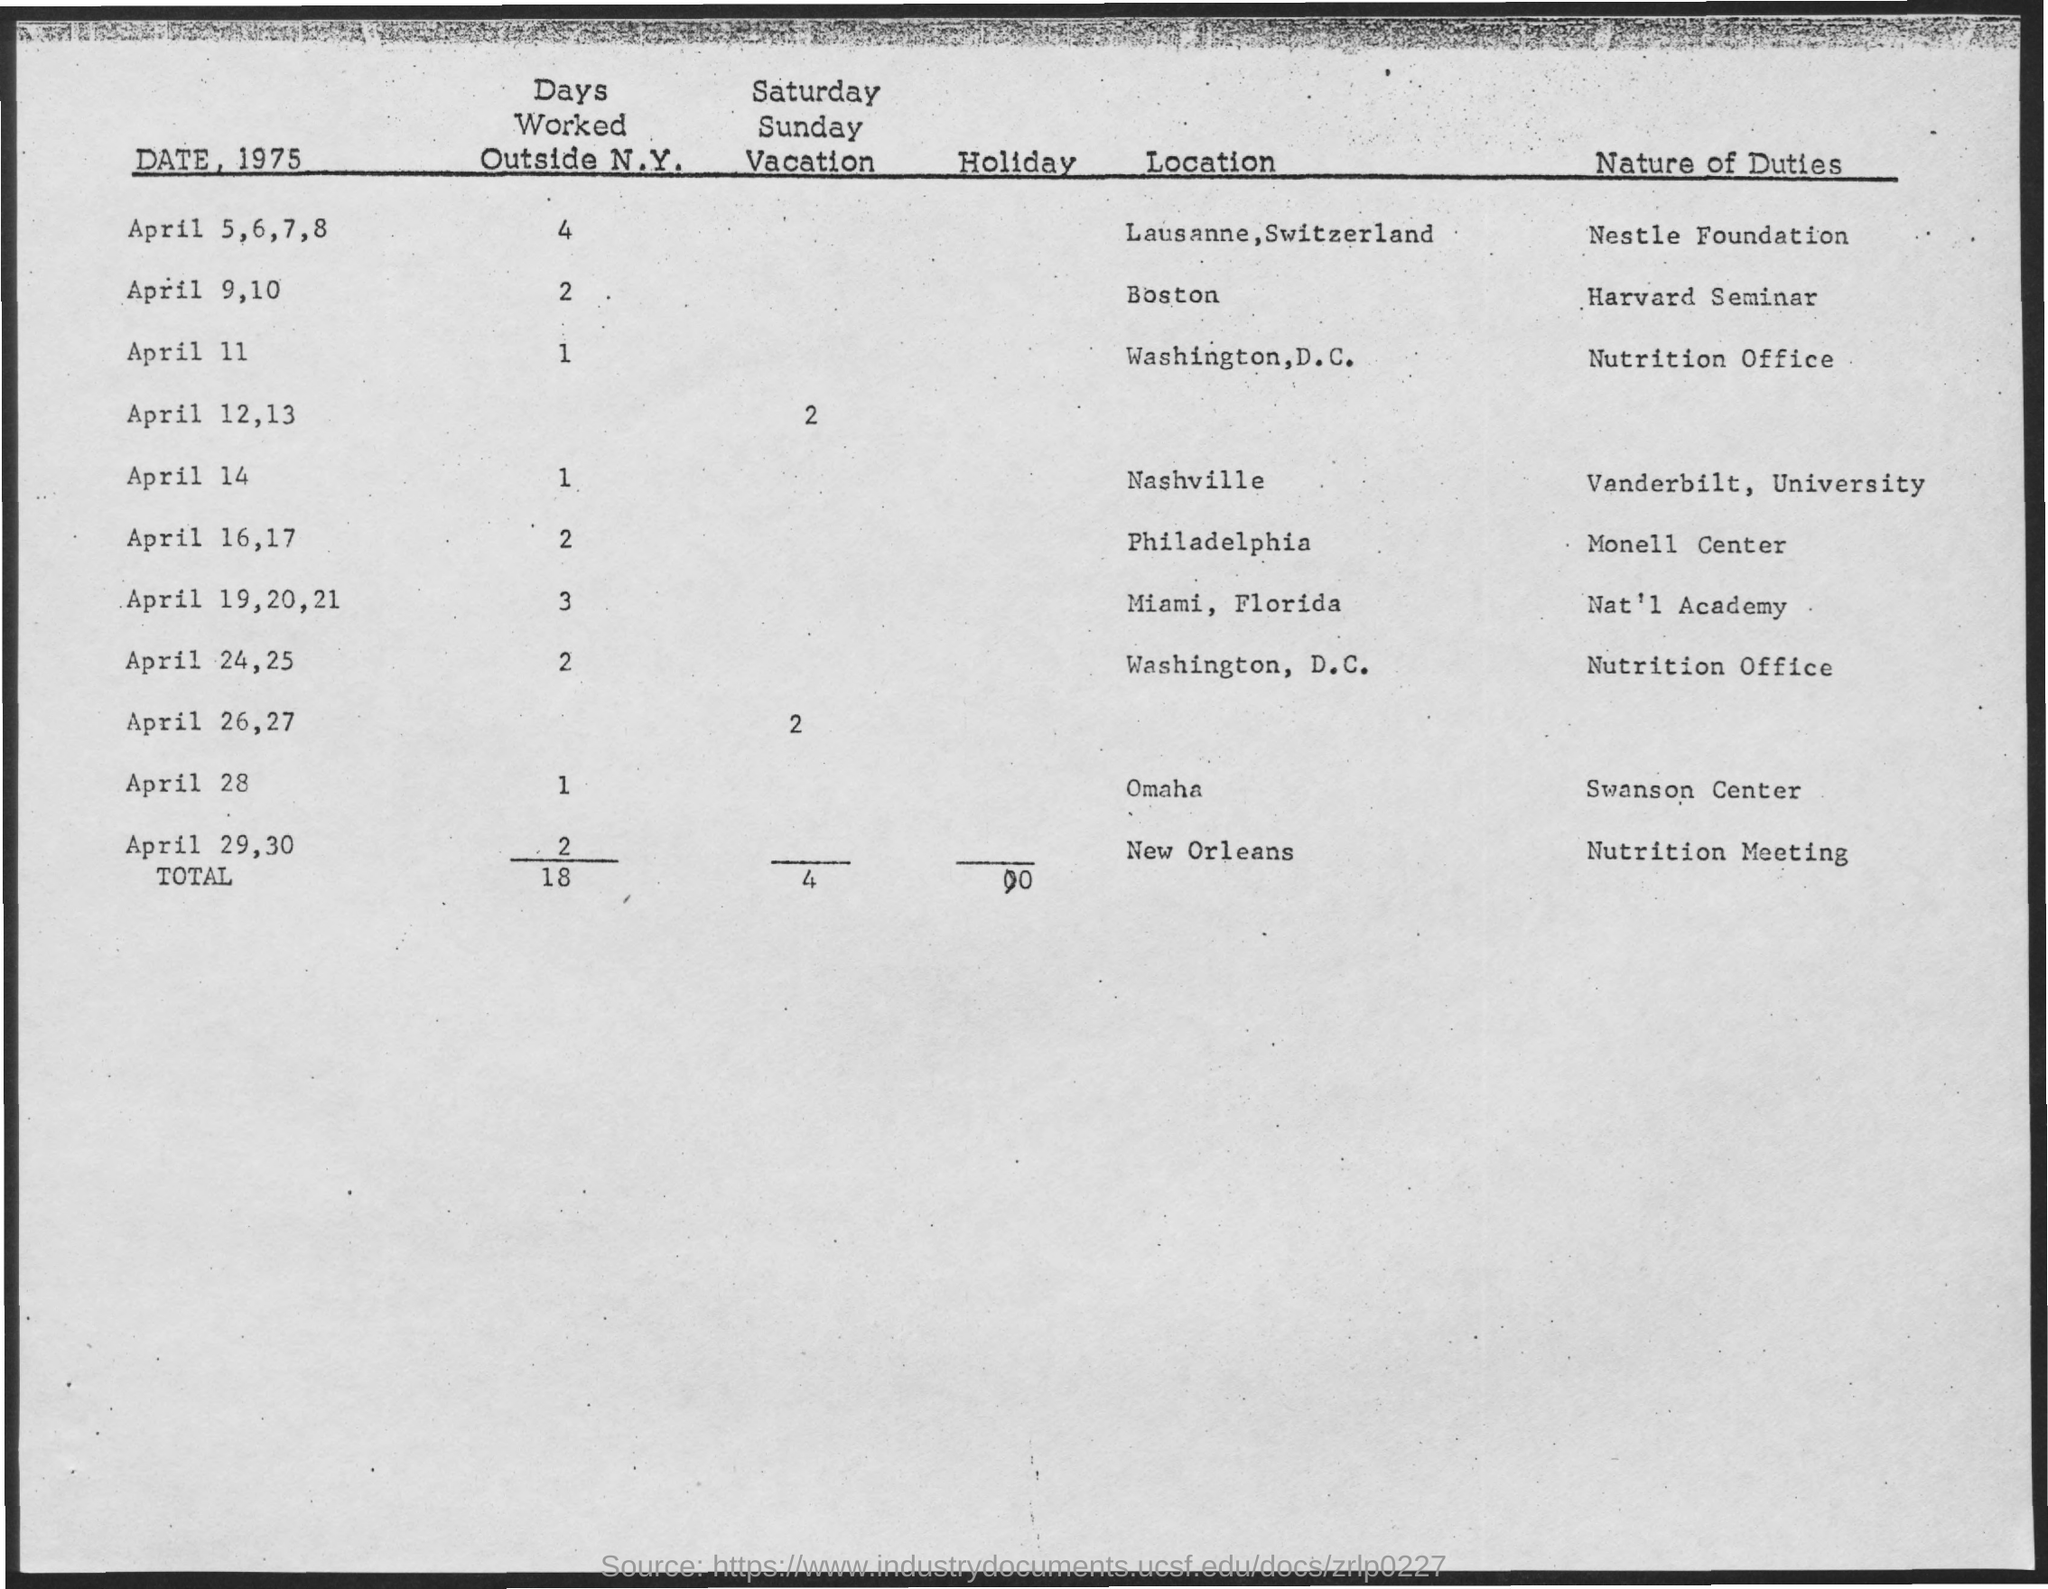Outline some significant characteristics in this image. On April 11, the number of days worked outside of New York is 1. The nature of duty on April 11 at the nutrition office is unknown. On April 28, the nature of duty is a question at the Swanson Center. The total number of days worked outside New York is 18 days. The total number of Saturday and Sunday vacations is 4. 